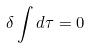Convert formula to latex. <formula><loc_0><loc_0><loc_500><loc_500>\delta \int d \tau = 0</formula> 